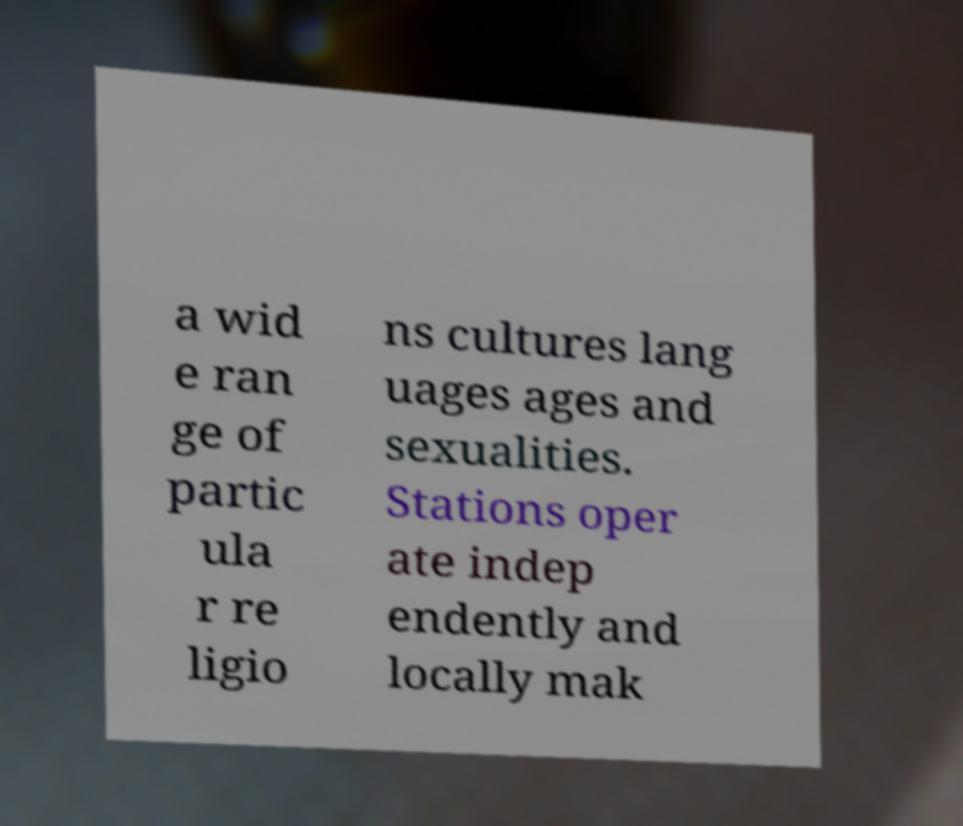Please read and relay the text visible in this image. What does it say? a wid e ran ge of partic ula r re ligio ns cultures lang uages ages and sexualities. Stations oper ate indep endently and locally mak 